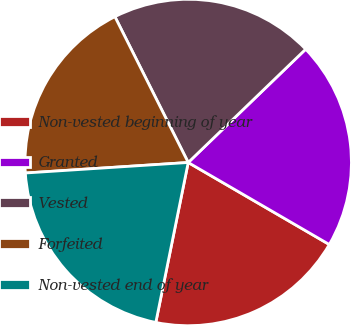Convert chart. <chart><loc_0><loc_0><loc_500><loc_500><pie_chart><fcel>Non-vested beginning of year<fcel>Granted<fcel>Vested<fcel>Forfeited<fcel>Non-vested end of year<nl><fcel>19.8%<fcel>20.59%<fcel>20.2%<fcel>18.61%<fcel>20.79%<nl></chart> 